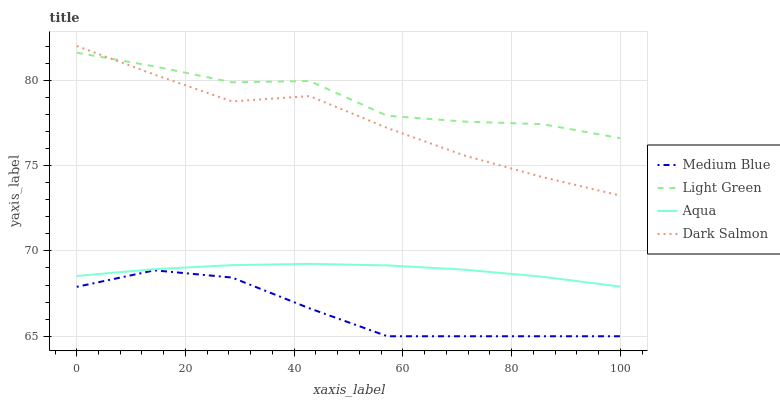Does Medium Blue have the minimum area under the curve?
Answer yes or no. Yes. Does Light Green have the maximum area under the curve?
Answer yes or no. Yes. Does Dark Salmon have the minimum area under the curve?
Answer yes or no. No. Does Dark Salmon have the maximum area under the curve?
Answer yes or no. No. Is Aqua the smoothest?
Answer yes or no. Yes. Is Light Green the roughest?
Answer yes or no. Yes. Is Medium Blue the smoothest?
Answer yes or no. No. Is Medium Blue the roughest?
Answer yes or no. No. Does Medium Blue have the lowest value?
Answer yes or no. Yes. Does Dark Salmon have the lowest value?
Answer yes or no. No. Does Dark Salmon have the highest value?
Answer yes or no. Yes. Does Medium Blue have the highest value?
Answer yes or no. No. Is Aqua less than Dark Salmon?
Answer yes or no. Yes. Is Aqua greater than Medium Blue?
Answer yes or no. Yes. Does Light Green intersect Dark Salmon?
Answer yes or no. Yes. Is Light Green less than Dark Salmon?
Answer yes or no. No. Is Light Green greater than Dark Salmon?
Answer yes or no. No. Does Aqua intersect Dark Salmon?
Answer yes or no. No. 